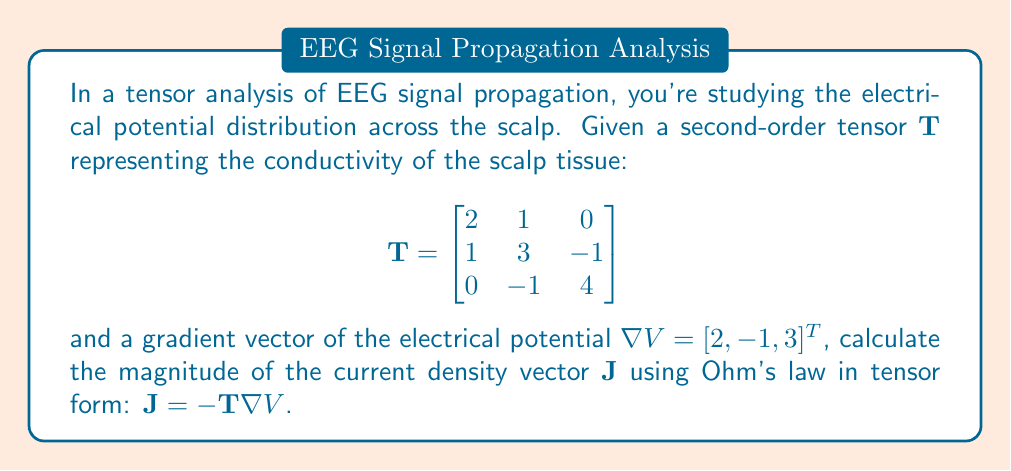Help me with this question. To solve this problem, we'll follow these steps:

1) First, recall Ohm's law in tensor form: $\mathbf{J} = -\mathbf{T}\nabla V$

2) We're given the conductivity tensor $\mathbf{T}$ and the gradient of the potential $\nabla V$. Let's perform the matrix multiplication:

   $$\mathbf{J} = -\begin{bmatrix}
   2 & 1 & 0 \\
   1 & 3 & -1 \\
   0 & -1 & 4
   \end{bmatrix} \begin{bmatrix}
   2 \\
   -1 \\
   3
   \end{bmatrix}$$

3) Multiplying the matrix and vector:

   $$\mathbf{J} = -\begin{bmatrix}
   (2 \cdot 2) + (1 \cdot -1) + (0 \cdot 3) \\
   (1 \cdot 2) + (3 \cdot -1) + (-1 \cdot 3) \\
   (0 \cdot 2) + (-1 \cdot -1) + (4 \cdot 3)
   \end{bmatrix}$$

4) Simplifying:

   $$\mathbf{J} = -\begin{bmatrix}
   4 - 1 + 0 \\
   2 - 3 - 3 \\
   0 + 1 + 12
   \end{bmatrix} = -\begin{bmatrix}
   3 \\
   -4 \\
   13
   \end{bmatrix}$$

5) Therefore, $\mathbf{J} = [-3, 4, -13]^T$

6) To find the magnitude of $\mathbf{J}$, we use the Euclidean norm:

   $$\|\mathbf{J}\| = \sqrt{(-3)^2 + 4^2 + (-13)^2}$$

7) Simplifying under the square root:

   $$\|\mathbf{J}\| = \sqrt{9 + 16 + 169} = \sqrt{194}$$

8) The final magnitude is $\sqrt{194}$.
Answer: $\sqrt{194}$ 